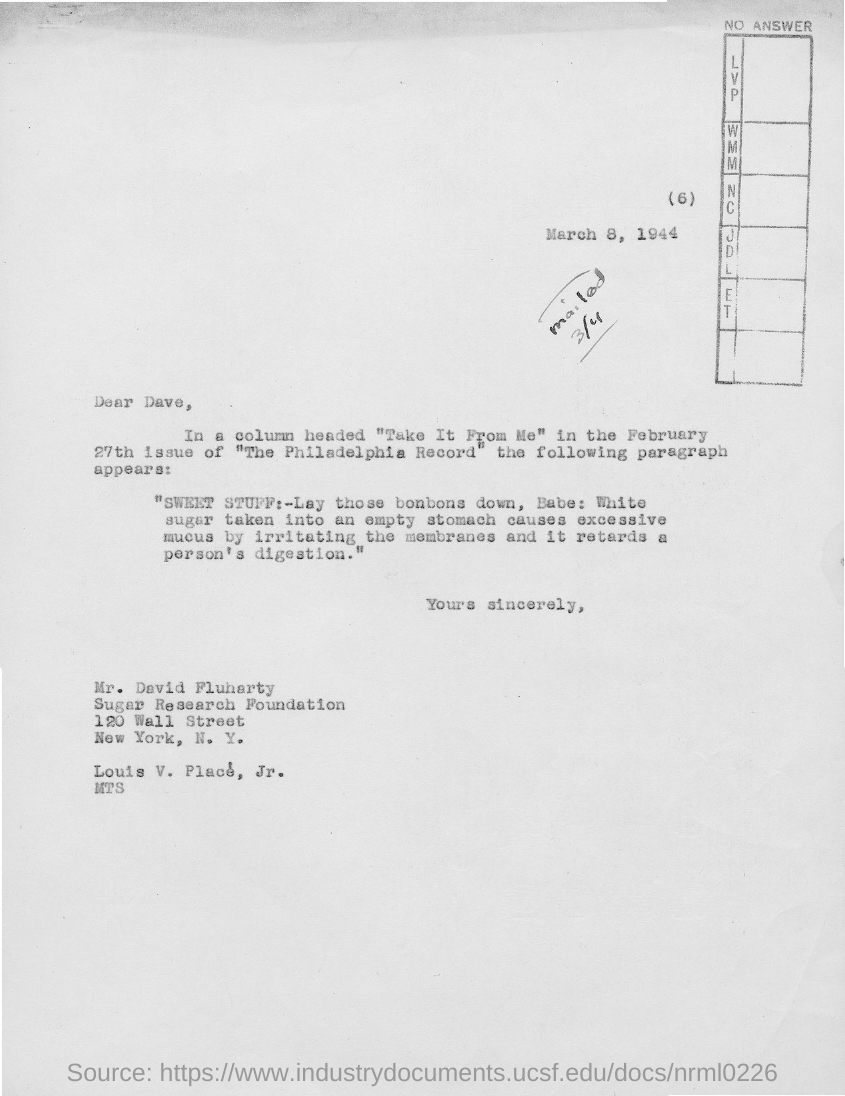Specify some key components in this picture. The date mentioned is March 8, 1944. The city where the Sugar Research Foundation is located is New York. The letter is addressed to Dave. 